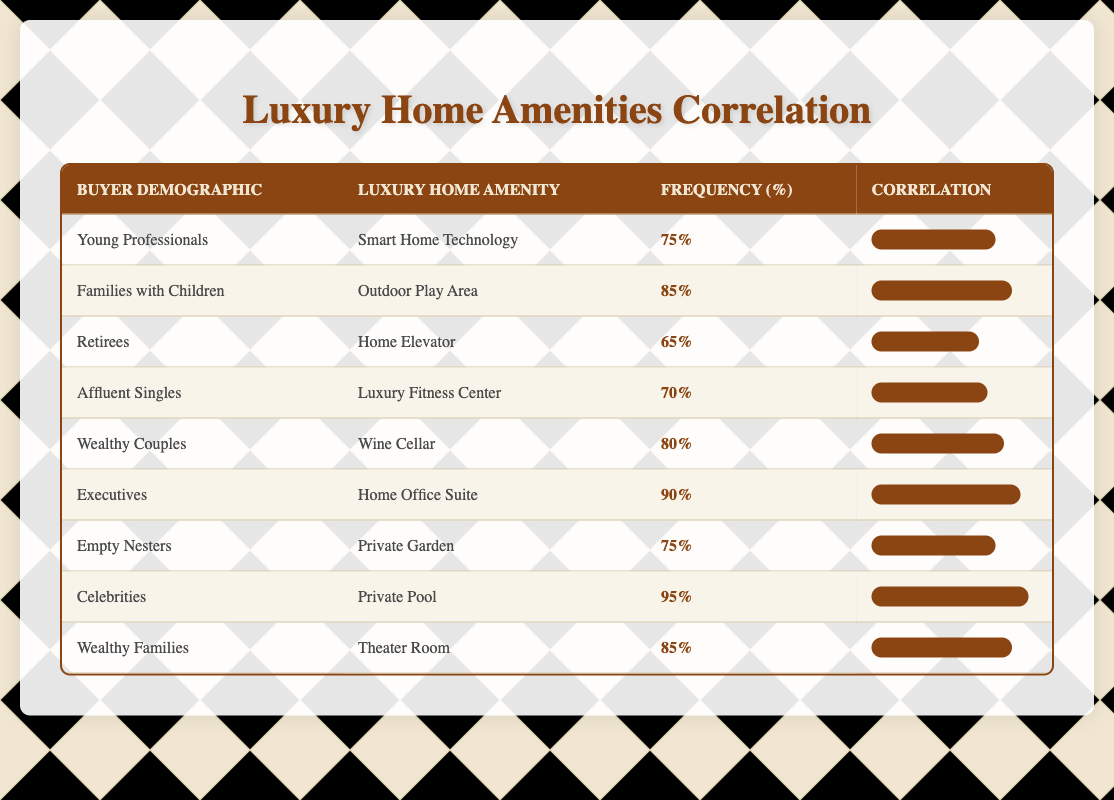What is the luxury home amenity that celebrities prefer the most? The table shows that celebrities have a frequency of 95% for the luxury amenity "Private Pool". Therefore, the preferred amenity for celebrities is the Private Pool.
Answer: Private Pool Which buyer demographic favors outdoor play areas the most? The data reveals that "Families with Children" have a frequency of 85% for the outdoor play area, indicating that this demographic favors this amenity the most.
Answer: Families with Children What is the frequency percentage for home elevators used by retirees? According to the table, retirees have a frequency of 65% for the home elevator amenity. Hence, the frequency percentage is 65%.
Answer: 65% What is the average frequency of luxury home amenities for affluent singles and wealthy couples? The frequency for affluent singles is 70% and for wealthy couples is 80%. To find the average, we sum these frequencies (70 + 80 = 150) and divide by 2, yielding an average of 75%.
Answer: 75% Are luxury fitness centers preferred by the same percentage of affluent singles and retirees? Affluent singles have a frequency of 70% for luxury fitness centers, while retirees have 65% for home elevators, which means they prefer different amenities at different percentages. Hence the statement is false.
Answer: No Which buyer demographics have a frequency of 75% for their preferred amenities? Two buyer demographics, "Young Professionals" and "Empty Nesters," both have a frequency of 75% for their respective amenities. Thus, they share the same frequency.
Answer: Young Professionals, Empty Nesters How many buyer demographics have a frequency of 85% or higher? The buyer demographics include "Families with Children," "Celebrities," and "Wealthy Families," which all have frequencies of 85% or higher (85%, 95%, and 85%, respectively). Therefore, a total of three demographics fit this criterion.
Answer: 3 What is the difference in frequency between the highest and lowest value for home amenities? The highest frequency is 95% for the "Private Pool" used by celebrities, while the lowest is 65% for the "Home Elevator" utilized by retirees. The difference is calculated as 95 - 65 = 30.
Answer: 30 Which demographic values wine cellars the most, and how does it compare to the frequency for home office suites? Wealthy Couples value wine cellars the most at a frequency of 80%. In comparison, Executives value home office suites at 90%. Therefore, the preference for wine cellars is lower by 10 percentage points compared to home office suites.
Answer: Lower by 10 percentage points 